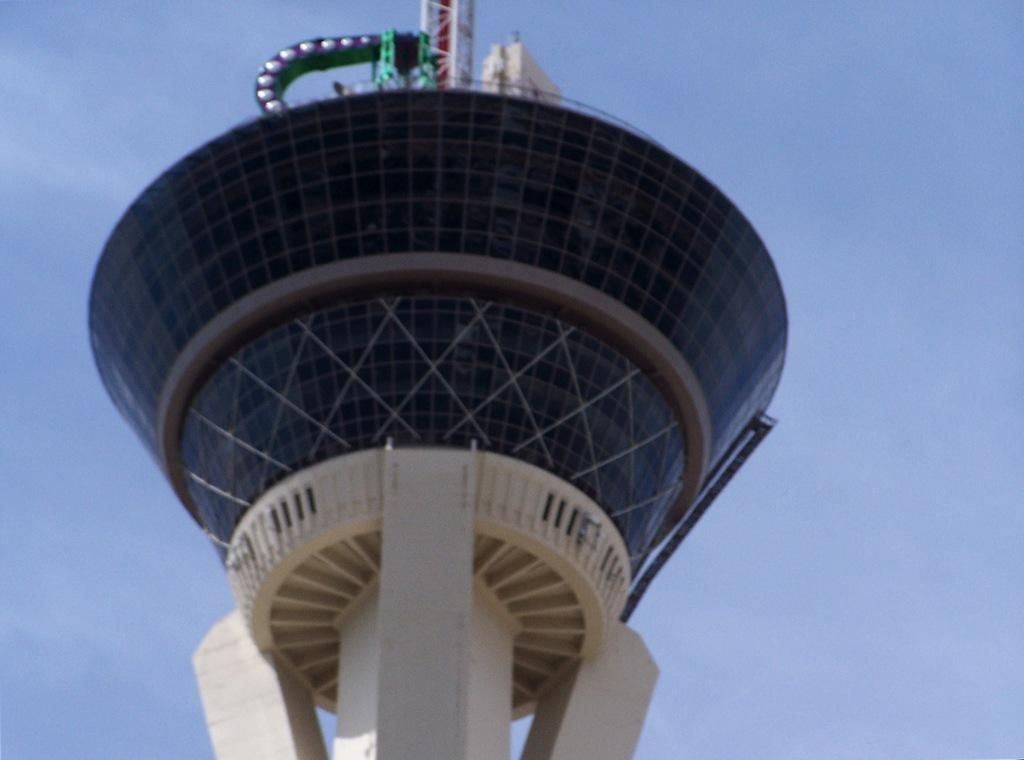What is the main structure in the middle of the image? There is a tower in the middle of the image. What is unique about the tower? The tower has glasses and pillars associated with it. What can be seen at the top of the tower? There are poles at the top of the tower. What is the color of the sky in the background of the image? The sky in the background of the image is blue. Can you tell me how many clovers are growing around the tower in the image? There are no clovers present in the image; the focus is on the tower and its features. 